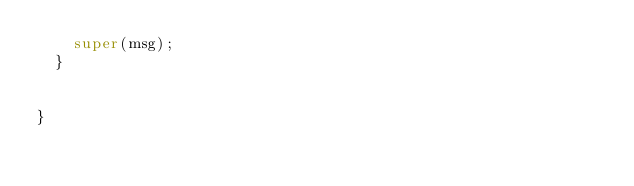Convert code to text. <code><loc_0><loc_0><loc_500><loc_500><_Java_>		super(msg);
	}

	
}
</code> 